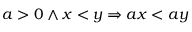Convert formula to latex. <formula><loc_0><loc_0><loc_500><loc_500>a > 0 \land x < y \Rightarrow a x < a y</formula> 